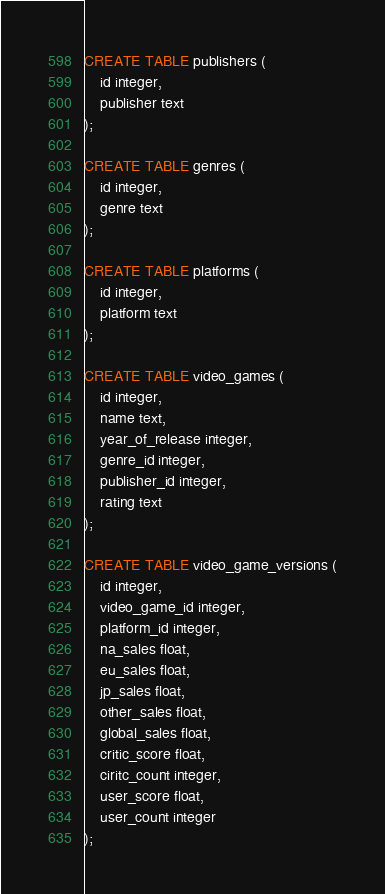Convert code to text. <code><loc_0><loc_0><loc_500><loc_500><_SQL_>CREATE TABLE publishers (
	id integer,
	publisher text
);

CREATE TABLE genres (
	id integer,
	genre text
);

CREATE TABLE platforms (
	id integer,
	platform text
);

CREATE TABLE video_games (
	id integer,
	name text,
	year_of_release integer,
	genre_id integer,
	publisher_id integer,
	rating text
);

CREATE TABLE video_game_versions (
	id integer,
	video_game_id integer,
	platform_id integer,
	na_sales float,
	eu_sales float,
	jp_sales float,
	other_sales float,
	global_sales float,
	critic_score float,
	ciritc_count integer,
	user_score float,
	user_count integer
);</code> 